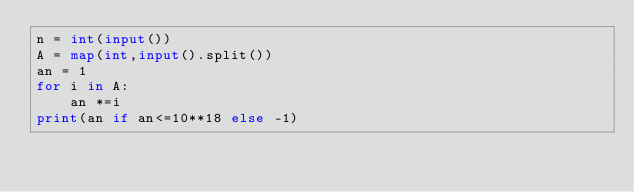<code> <loc_0><loc_0><loc_500><loc_500><_Python_>n = int(input())
A = map(int,input().split())
an = 1
for i in A:
    an *=i
print(an if an<=10**18 else -1)</code> 